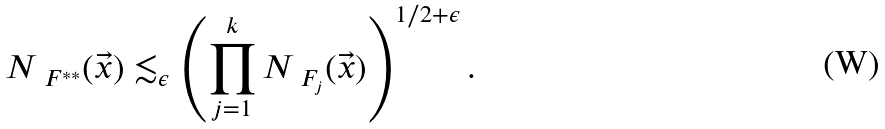Convert formula to latex. <formula><loc_0><loc_0><loc_500><loc_500>N _ { \ F ^ { * * } } ( \vec { x } ) \lesssim _ { \epsilon } \left ( \prod _ { j = 1 } ^ { k } N _ { \ F _ { j } } ( \vec { x } ) \right ) ^ { 1 / 2 + \epsilon } .</formula> 